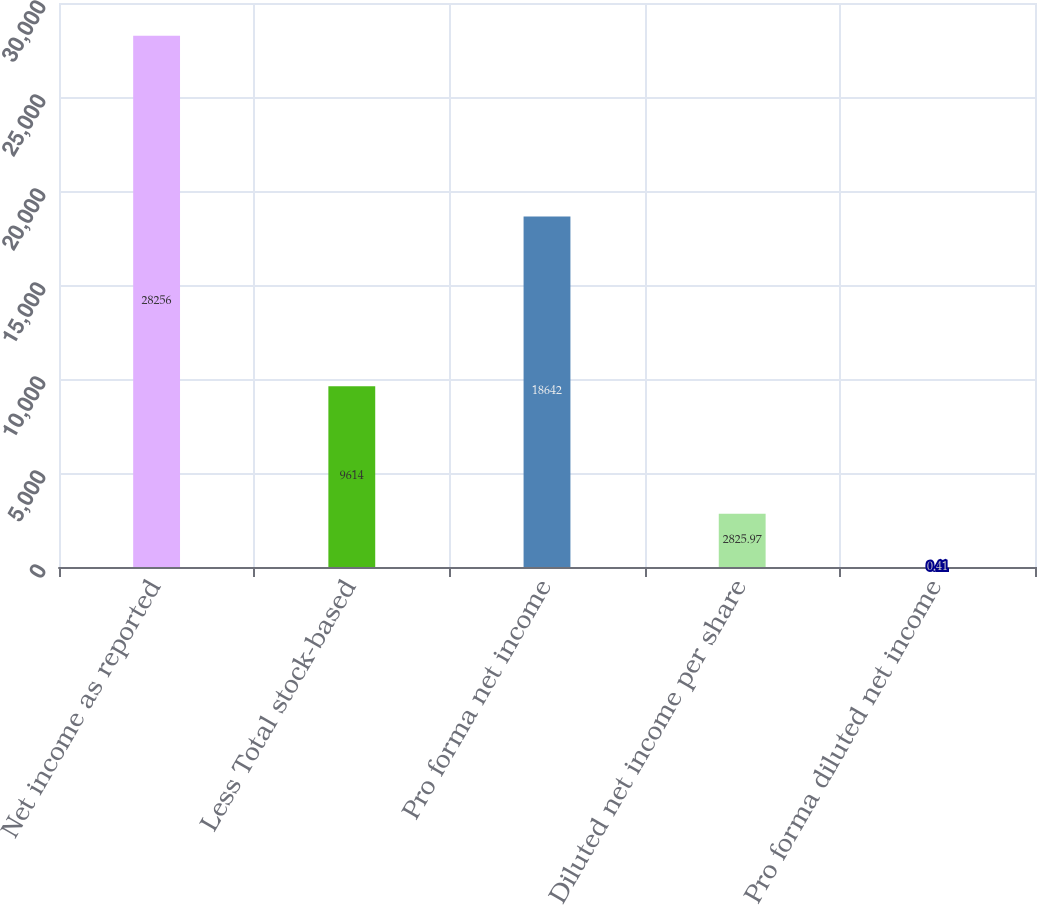Convert chart. <chart><loc_0><loc_0><loc_500><loc_500><bar_chart><fcel>Net income as reported<fcel>Less Total stock-based<fcel>Pro forma net income<fcel>Diluted net income per share<fcel>Pro forma diluted net income<nl><fcel>28256<fcel>9614<fcel>18642<fcel>2825.97<fcel>0.41<nl></chart> 